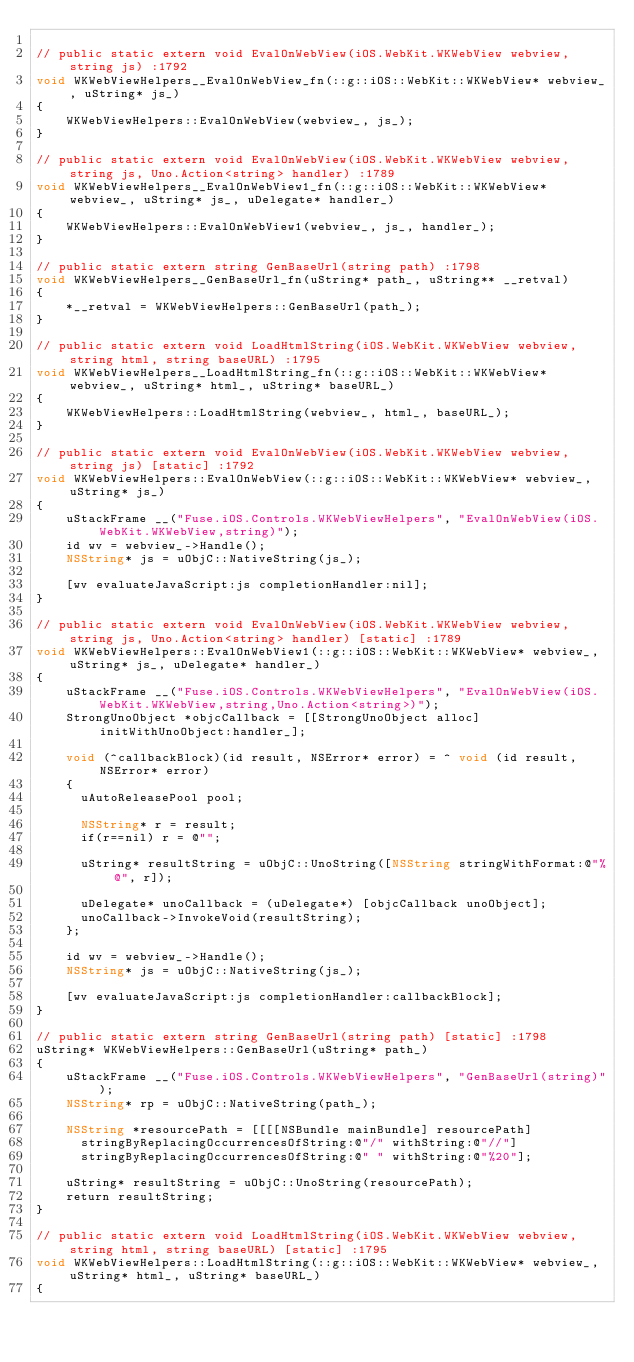<code> <loc_0><loc_0><loc_500><loc_500><_ObjectiveC_>
// public static extern void EvalOnWebView(iOS.WebKit.WKWebView webview, string js) :1792
void WKWebViewHelpers__EvalOnWebView_fn(::g::iOS::WebKit::WKWebView* webview_, uString* js_)
{
    WKWebViewHelpers::EvalOnWebView(webview_, js_);
}

// public static extern void EvalOnWebView(iOS.WebKit.WKWebView webview, string js, Uno.Action<string> handler) :1789
void WKWebViewHelpers__EvalOnWebView1_fn(::g::iOS::WebKit::WKWebView* webview_, uString* js_, uDelegate* handler_)
{
    WKWebViewHelpers::EvalOnWebView1(webview_, js_, handler_);
}

// public static extern string GenBaseUrl(string path) :1798
void WKWebViewHelpers__GenBaseUrl_fn(uString* path_, uString** __retval)
{
    *__retval = WKWebViewHelpers::GenBaseUrl(path_);
}

// public static extern void LoadHtmlString(iOS.WebKit.WKWebView webview, string html, string baseURL) :1795
void WKWebViewHelpers__LoadHtmlString_fn(::g::iOS::WebKit::WKWebView* webview_, uString* html_, uString* baseURL_)
{
    WKWebViewHelpers::LoadHtmlString(webview_, html_, baseURL_);
}

// public static extern void EvalOnWebView(iOS.WebKit.WKWebView webview, string js) [static] :1792
void WKWebViewHelpers::EvalOnWebView(::g::iOS::WebKit::WKWebView* webview_, uString* js_)
{
    uStackFrame __("Fuse.iOS.Controls.WKWebViewHelpers", "EvalOnWebView(iOS.WebKit.WKWebView,string)");
    id wv = webview_->Handle();
    NSString* js = uObjC::NativeString(js_);
    
    [wv evaluateJavaScript:js completionHandler:nil];
}

// public static extern void EvalOnWebView(iOS.WebKit.WKWebView webview, string js, Uno.Action<string> handler) [static] :1789
void WKWebViewHelpers::EvalOnWebView1(::g::iOS::WebKit::WKWebView* webview_, uString* js_, uDelegate* handler_)
{
    uStackFrame __("Fuse.iOS.Controls.WKWebViewHelpers", "EvalOnWebView(iOS.WebKit.WKWebView,string,Uno.Action<string>)");
    StrongUnoObject *objcCallback = [[StrongUnoObject alloc] initWithUnoObject:handler_];
    
    void (^callbackBlock)(id result, NSError* error) = ^ void (id result, NSError* error) 
    {
    	uAutoReleasePool pool;
    
    	NSString* r = result;
    	if(r==nil) r = @"";
    
    	uString* resultString = uObjC::UnoString([NSString stringWithFormat:@"%@", r]);
    
    	uDelegate* unoCallback = (uDelegate*) [objcCallback unoObject];
    	unoCallback->InvokeVoid(resultString);
    };
    
    id wv = webview_->Handle();
    NSString* js = uObjC::NativeString(js_);
    
    [wv evaluateJavaScript:js completionHandler:callbackBlock];
}

// public static extern string GenBaseUrl(string path) [static] :1798
uString* WKWebViewHelpers::GenBaseUrl(uString* path_)
{
    uStackFrame __("Fuse.iOS.Controls.WKWebViewHelpers", "GenBaseUrl(string)");
    NSString* rp = uObjC::NativeString(path_);
    
    NSString *resourcePath = [[[[NSBundle mainBundle] resourcePath]
    	stringByReplacingOccurrencesOfString:@"/" withString:@"//"]
    	stringByReplacingOccurrencesOfString:@" " withString:@"%20"];
    
    uString* resultString = uObjC::UnoString(resourcePath);
    return resultString;
}

// public static extern void LoadHtmlString(iOS.WebKit.WKWebView webview, string html, string baseURL) [static] :1795
void WKWebViewHelpers::LoadHtmlString(::g::iOS::WebKit::WKWebView* webview_, uString* html_, uString* baseURL_)
{</code> 